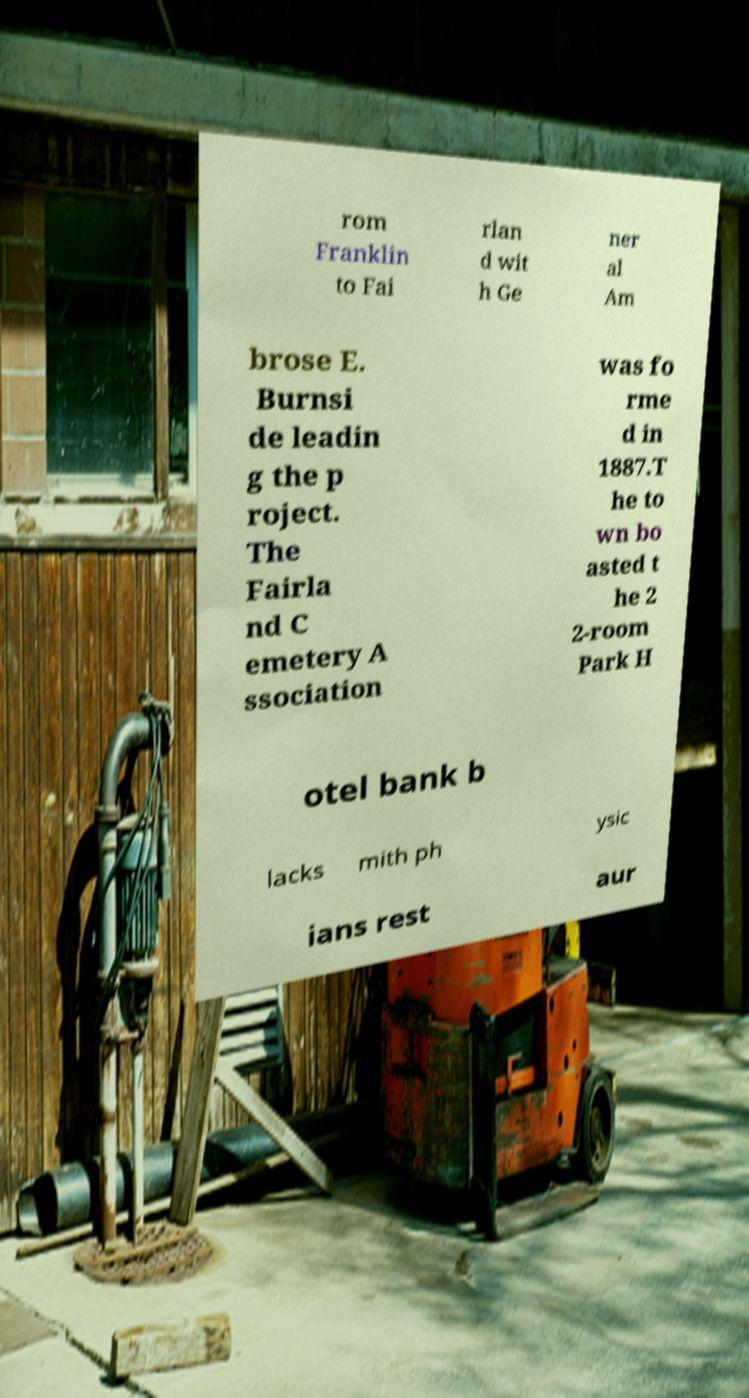Please identify and transcribe the text found in this image. rom Franklin to Fai rlan d wit h Ge ner al Am brose E. Burnsi de leadin g the p roject. The Fairla nd C emetery A ssociation was fo rme d in 1887.T he to wn bo asted t he 2 2-room Park H otel bank b lacks mith ph ysic ians rest aur 